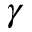Convert formula to latex. <formula><loc_0><loc_0><loc_500><loc_500>\gamma</formula> 